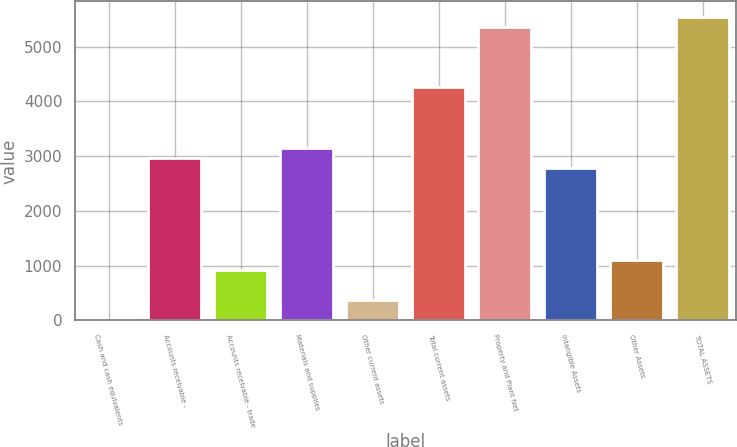Convert chart to OTSL. <chart><loc_0><loc_0><loc_500><loc_500><bar_chart><fcel>Cash and cash equivalents<fcel>Accounts receivable -<fcel>Accounts receivable - trade<fcel>Materials and supplies<fcel>Other current assets<fcel>Total current assets<fcel>Property and Plant Net<fcel>Intangible Assets<fcel>Other Assets<fcel>TOTAL ASSETS<nl><fcel>1<fcel>2959.4<fcel>925.5<fcel>3144.3<fcel>370.8<fcel>4253.7<fcel>5363.1<fcel>2774.5<fcel>1110.4<fcel>5548<nl></chart> 